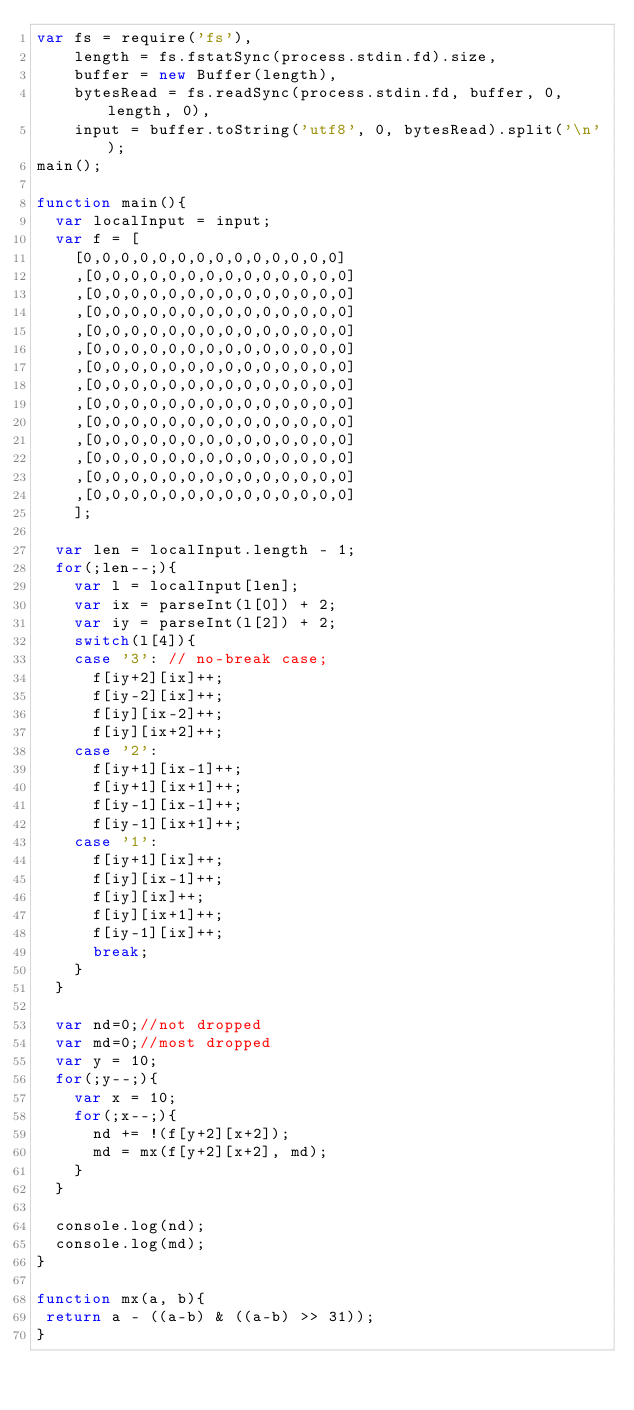<code> <loc_0><loc_0><loc_500><loc_500><_JavaScript_>var fs = require('fs'),
    length = fs.fstatSync(process.stdin.fd).size,
    buffer = new Buffer(length),
    bytesRead = fs.readSync(process.stdin.fd, buffer, 0, length, 0),
    input = buffer.toString('utf8', 0, bytesRead).split('\n');
main();

function main(){
  var localInput = input;
  var f = [
    [0,0,0,0,0,0,0,0,0,0,0,0,0,0]
    ,[0,0,0,0,0,0,0,0,0,0,0,0,0,0]
    ,[0,0,0,0,0,0,0,0,0,0,0,0,0,0]
    ,[0,0,0,0,0,0,0,0,0,0,0,0,0,0]
    ,[0,0,0,0,0,0,0,0,0,0,0,0,0,0]
    ,[0,0,0,0,0,0,0,0,0,0,0,0,0,0]
    ,[0,0,0,0,0,0,0,0,0,0,0,0,0,0]
    ,[0,0,0,0,0,0,0,0,0,0,0,0,0,0]
    ,[0,0,0,0,0,0,0,0,0,0,0,0,0,0]
    ,[0,0,0,0,0,0,0,0,0,0,0,0,0,0]
    ,[0,0,0,0,0,0,0,0,0,0,0,0,0,0]
    ,[0,0,0,0,0,0,0,0,0,0,0,0,0,0]
    ,[0,0,0,0,0,0,0,0,0,0,0,0,0,0]
    ,[0,0,0,0,0,0,0,0,0,0,0,0,0,0]
    ];
  
  var len = localInput.length - 1;
  for(;len--;){
    var l = localInput[len];
    var ix = parseInt(l[0]) + 2;
    var iy = parseInt(l[2]) + 2;
    switch(l[4]){
    case '3': // no-break case;
      f[iy+2][ix]++;
      f[iy-2][ix]++;
      f[iy][ix-2]++;
      f[iy][ix+2]++;
    case '2':
      f[iy+1][ix-1]++;
      f[iy+1][ix+1]++;
      f[iy-1][ix-1]++;
      f[iy-1][ix+1]++;
    case '1':
      f[iy+1][ix]++;
      f[iy][ix-1]++;
      f[iy][ix]++;
      f[iy][ix+1]++;
      f[iy-1][ix]++;
      break;
    }
  }
  
  var nd=0;//not dropped
  var md=0;//most dropped
  var y = 10;
  for(;y--;){
    var x = 10;
    for(;x--;){
      nd += !(f[y+2][x+2]);
      md = mx(f[y+2][x+2], md);
    }
  }
  
  console.log(nd);
  console.log(md);
}
   
function mx(a, b){
 return a - ((a-b) & ((a-b) >> 31));
}</code> 